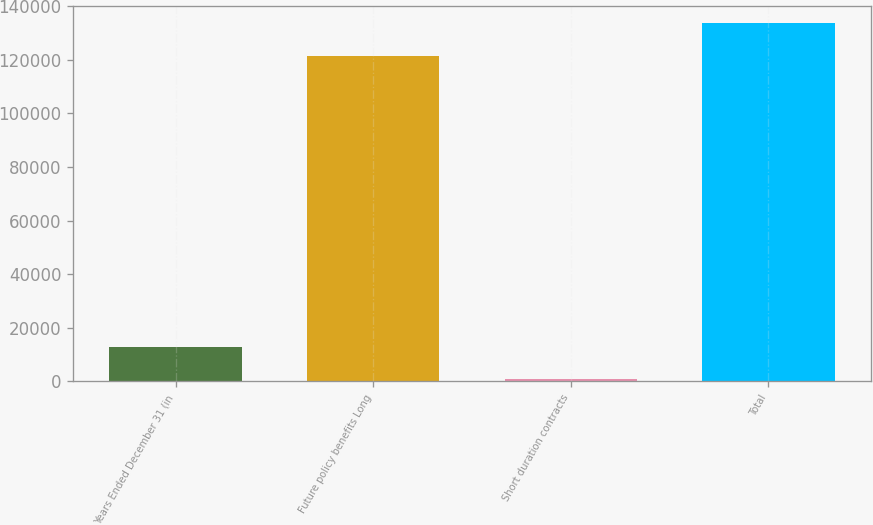Convert chart. <chart><loc_0><loc_0><loc_500><loc_500><bar_chart><fcel>Years Ended December 31 (in<fcel>Future policy benefits Long<fcel>Short duration contracts<fcel>Total<nl><fcel>13002.4<fcel>121364<fcel>866<fcel>133500<nl></chart> 